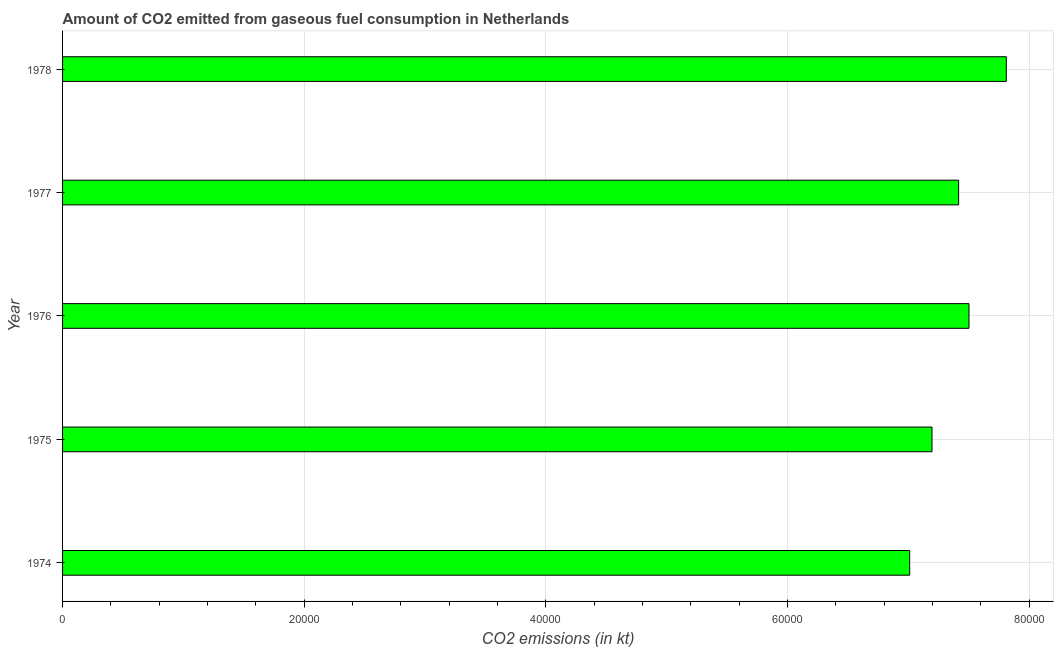What is the title of the graph?
Your answer should be compact. Amount of CO2 emitted from gaseous fuel consumption in Netherlands. What is the label or title of the X-axis?
Offer a very short reply. CO2 emissions (in kt). What is the label or title of the Y-axis?
Your answer should be compact. Year. What is the co2 emissions from gaseous fuel consumption in 1976?
Offer a terse response. 7.50e+04. Across all years, what is the maximum co2 emissions from gaseous fuel consumption?
Your response must be concise. 7.81e+04. Across all years, what is the minimum co2 emissions from gaseous fuel consumption?
Make the answer very short. 7.01e+04. In which year was the co2 emissions from gaseous fuel consumption maximum?
Offer a very short reply. 1978. In which year was the co2 emissions from gaseous fuel consumption minimum?
Your answer should be compact. 1974. What is the sum of the co2 emissions from gaseous fuel consumption?
Your answer should be compact. 3.69e+05. What is the difference between the co2 emissions from gaseous fuel consumption in 1976 and 1977?
Provide a succinct answer. 858.08. What is the average co2 emissions from gaseous fuel consumption per year?
Make the answer very short. 7.39e+04. What is the median co2 emissions from gaseous fuel consumption?
Give a very brief answer. 7.42e+04. Do a majority of the years between 1974 and 1978 (inclusive) have co2 emissions from gaseous fuel consumption greater than 32000 kt?
Make the answer very short. Yes. Is the difference between the co2 emissions from gaseous fuel consumption in 1976 and 1978 greater than the difference between any two years?
Your answer should be compact. No. What is the difference between the highest and the second highest co2 emissions from gaseous fuel consumption?
Your answer should be compact. 3087.61. What is the difference between the highest and the lowest co2 emissions from gaseous fuel consumption?
Your answer should be very brief. 7997.73. How many bars are there?
Give a very brief answer. 5. What is the difference between two consecutive major ticks on the X-axis?
Your answer should be very brief. 2.00e+04. Are the values on the major ticks of X-axis written in scientific E-notation?
Make the answer very short. No. What is the CO2 emissions (in kt) in 1974?
Offer a terse response. 7.01e+04. What is the CO2 emissions (in kt) in 1975?
Make the answer very short. 7.20e+04. What is the CO2 emissions (in kt) in 1976?
Provide a short and direct response. 7.50e+04. What is the CO2 emissions (in kt) in 1977?
Provide a succinct answer. 7.42e+04. What is the CO2 emissions (in kt) of 1978?
Your answer should be compact. 7.81e+04. What is the difference between the CO2 emissions (in kt) in 1974 and 1975?
Keep it short and to the point. -1848.17. What is the difference between the CO2 emissions (in kt) in 1974 and 1976?
Provide a short and direct response. -4910.11. What is the difference between the CO2 emissions (in kt) in 1974 and 1977?
Your response must be concise. -4052.03. What is the difference between the CO2 emissions (in kt) in 1974 and 1978?
Give a very brief answer. -7997.73. What is the difference between the CO2 emissions (in kt) in 1975 and 1976?
Your response must be concise. -3061.95. What is the difference between the CO2 emissions (in kt) in 1975 and 1977?
Provide a succinct answer. -2203.87. What is the difference between the CO2 emissions (in kt) in 1975 and 1978?
Offer a very short reply. -6149.56. What is the difference between the CO2 emissions (in kt) in 1976 and 1977?
Ensure brevity in your answer.  858.08. What is the difference between the CO2 emissions (in kt) in 1976 and 1978?
Provide a short and direct response. -3087.61. What is the difference between the CO2 emissions (in kt) in 1977 and 1978?
Provide a short and direct response. -3945.69. What is the ratio of the CO2 emissions (in kt) in 1974 to that in 1976?
Your answer should be very brief. 0.94. What is the ratio of the CO2 emissions (in kt) in 1974 to that in 1977?
Offer a terse response. 0.94. What is the ratio of the CO2 emissions (in kt) in 1974 to that in 1978?
Offer a very short reply. 0.9. What is the ratio of the CO2 emissions (in kt) in 1975 to that in 1978?
Your answer should be compact. 0.92. What is the ratio of the CO2 emissions (in kt) in 1976 to that in 1977?
Keep it short and to the point. 1.01. What is the ratio of the CO2 emissions (in kt) in 1977 to that in 1978?
Ensure brevity in your answer.  0.95. 